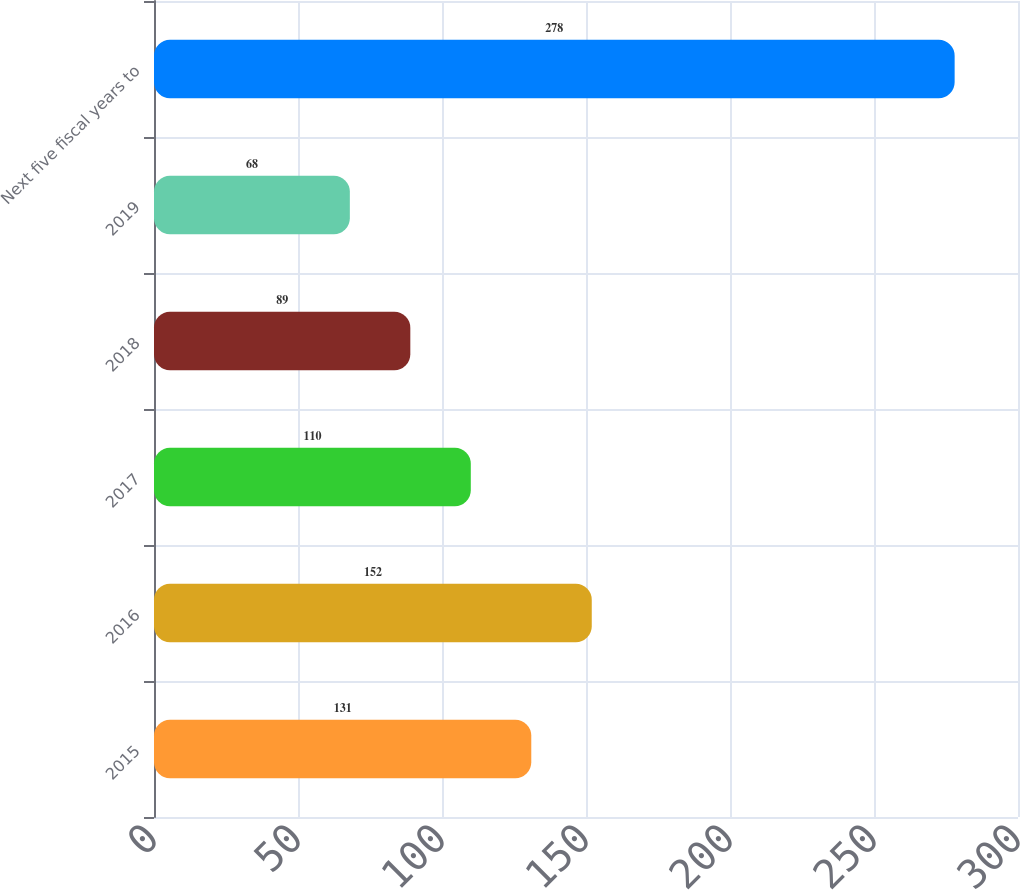<chart> <loc_0><loc_0><loc_500><loc_500><bar_chart><fcel>2015<fcel>2016<fcel>2017<fcel>2018<fcel>2019<fcel>Next five fiscal years to<nl><fcel>131<fcel>152<fcel>110<fcel>89<fcel>68<fcel>278<nl></chart> 